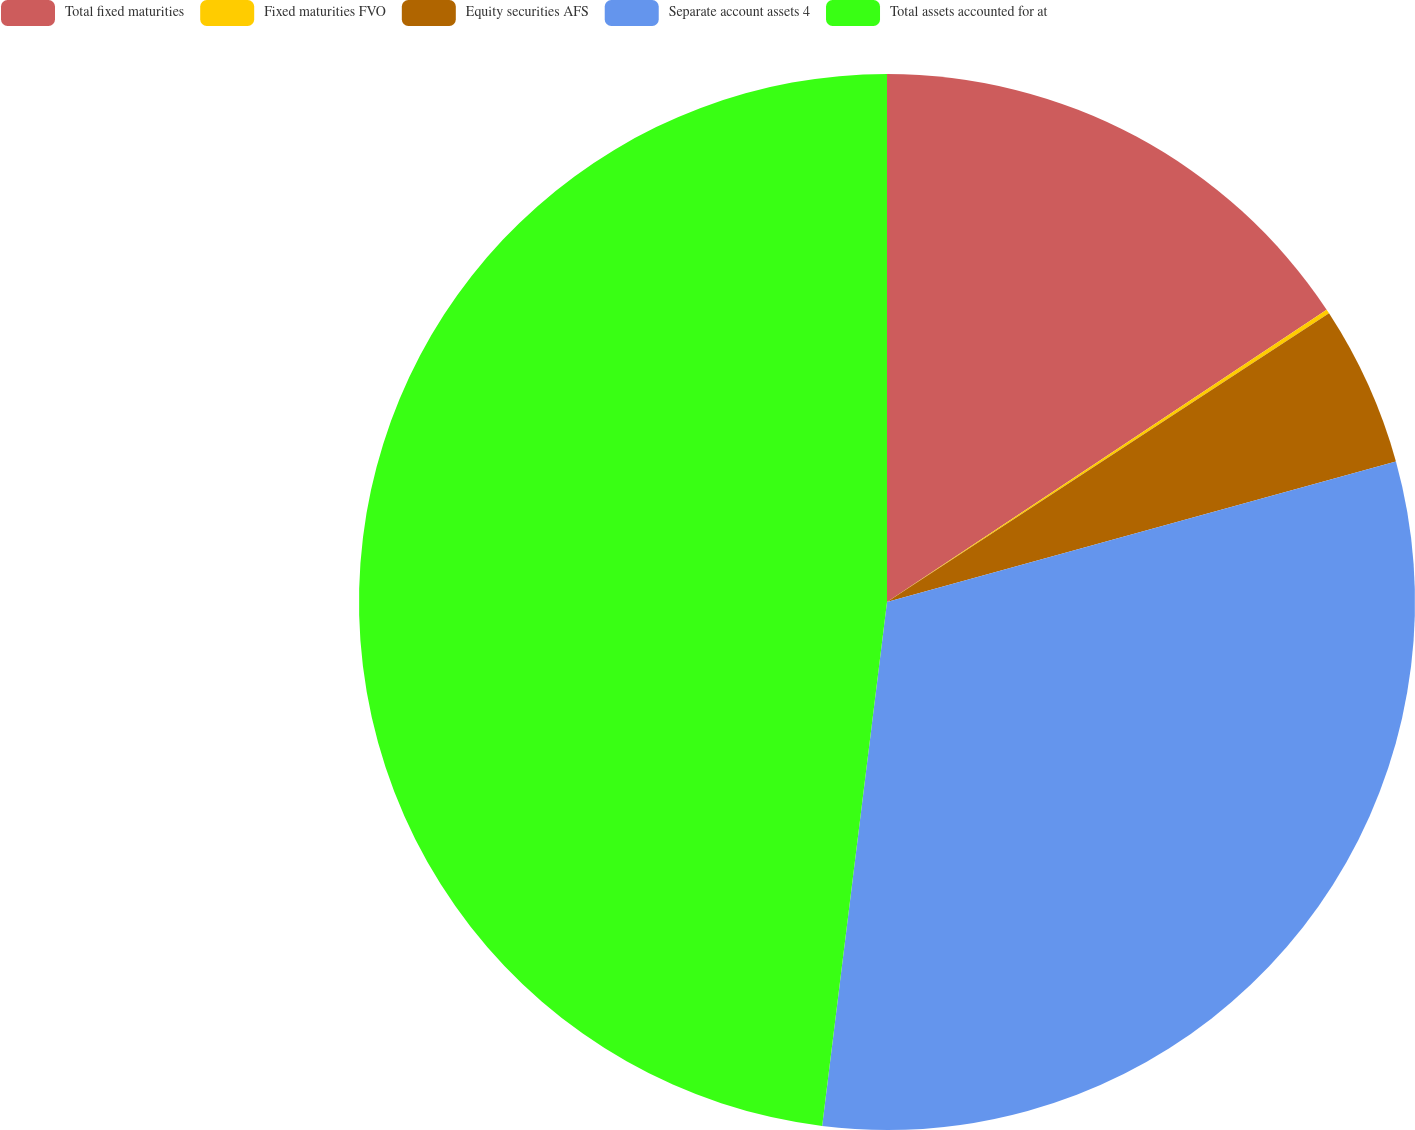<chart> <loc_0><loc_0><loc_500><loc_500><pie_chart><fcel>Total fixed maturities<fcel>Fixed maturities FVO<fcel>Equity securities AFS<fcel>Separate account assets 4<fcel>Total assets accounted for at<nl><fcel>15.66%<fcel>0.13%<fcel>4.92%<fcel>31.25%<fcel>48.04%<nl></chart> 